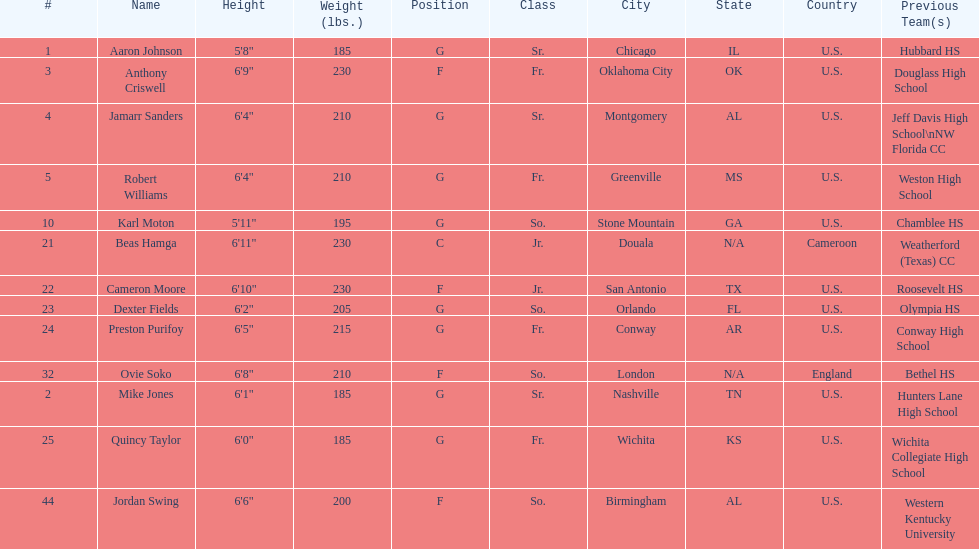How many players were on the 2010-11 uab blazers men's basketball team? 13. Parse the full table. {'header': ['#', 'Name', 'Height', 'Weight (lbs.)', 'Position', 'Class', 'City', 'State', 'Country', 'Previous Team(s)'], 'rows': [['1', 'Aaron Johnson', '5\'8"', '185', 'G', 'Sr.', 'Chicago', 'IL', 'U.S.', 'Hubbard HS'], ['3', 'Anthony Criswell', '6\'9"', '230', 'F', 'Fr.', 'Oklahoma City', 'OK', 'U.S.', 'Douglass High School'], ['4', 'Jamarr Sanders', '6\'4"', '210', 'G', 'Sr.', 'Montgomery', 'AL', 'U.S.', 'Jeff Davis High School\\nNW Florida CC'], ['5', 'Robert Williams', '6\'4"', '210', 'G', 'Fr.', 'Greenville', 'MS', 'U.S.', 'Weston High School'], ['10', 'Karl Moton', '5\'11"', '195', 'G', 'So.', 'Stone Mountain', 'GA', 'U.S.', 'Chamblee HS'], ['21', 'Beas Hamga', '6\'11"', '230', 'C', 'Jr.', 'Douala', 'N/A', 'Cameroon', 'Weatherford (Texas) CC'], ['22', 'Cameron Moore', '6\'10"', '230', 'F', 'Jr.', 'San Antonio', 'TX', 'U.S.', 'Roosevelt HS'], ['23', 'Dexter Fields', '6\'2"', '205', 'G', 'So.', 'Orlando', 'FL', 'U.S.', 'Olympia HS'], ['24', 'Preston Purifoy', '6\'5"', '215', 'G', 'Fr.', 'Conway', 'AR', 'U.S.', 'Conway High School'], ['32', 'Ovie Soko', '6\'8"', '210', 'F', 'So.', 'London', 'N/A', 'England', 'Bethel HS'], ['2', 'Mike Jones', '6\'1"', '185', 'G', 'Sr.', 'Nashville', 'TN', 'U.S.', 'Hunters Lane High School'], ['25', 'Quincy Taylor', '6\'0"', '185', 'G', 'Fr.', 'Wichita', 'KS', 'U.S.', 'Wichita Collegiate High School'], ['44', 'Jordan Swing', '6\'6"', '200', 'F', 'So.', 'Birmingham', 'AL', 'U.S.', 'Western Kentucky University']]} 